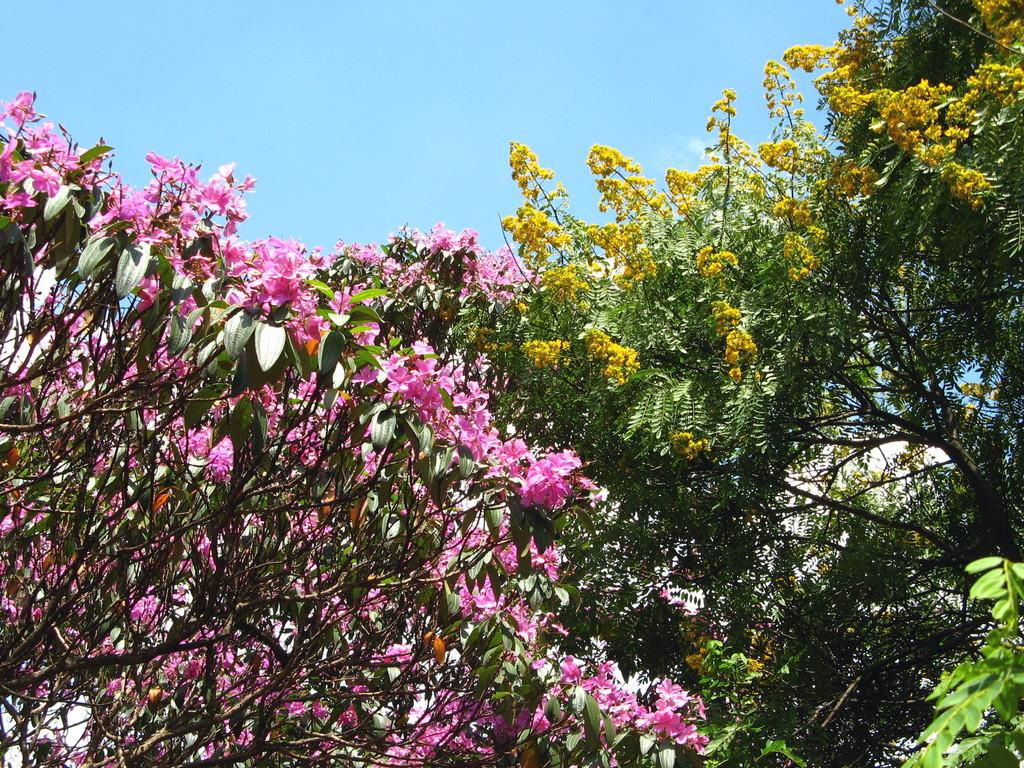What type of vegetation can be seen in the image? There are trees and flowers in the image. What color is the sky in the image? The sky is blue in the image. What type of disease is affecting the trees in the image? There is no indication of any disease affecting the trees in the image; they appear healthy. Can you tell me how many mothers are present in the image? There is no mention of any mothers in the image; it features trees, flowers, and a blue sky. 